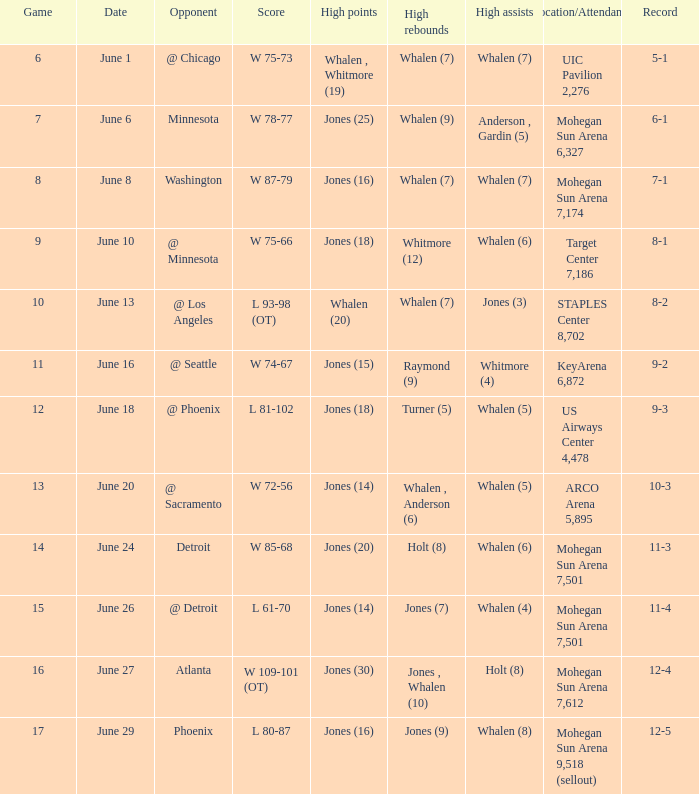What is the venue and the number of attendees when the record stands at 9-2? KeyArena 6,872. 